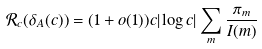<formula> <loc_0><loc_0><loc_500><loc_500>\mathcal { R } _ { c } ( \delta _ { A } ( c ) ) = ( 1 + o ( 1 ) ) c | \log c | \sum _ { m } \frac { \pi _ { m } } { I ( m ) }</formula> 